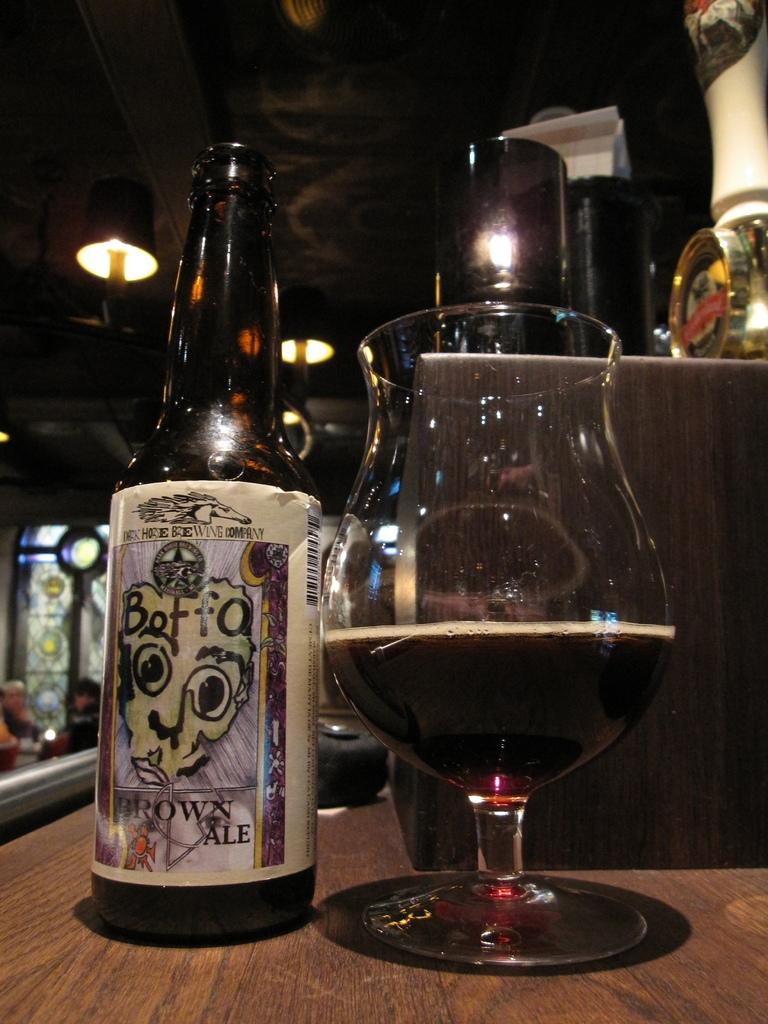What is in the glass that is visible in the image? There is a drink in the glass in the image. What else can be seen on the table besides the glass? There is a bottle and other objects on the table in the image. What can be seen in the background of the image? There are lights and people visible in the background. What type of order is being processed by the police in the image? There is no police or order being processed in the image; it only shows a glass with a drink, a bottle, and other objects on a table, along with lights and people in the background. 